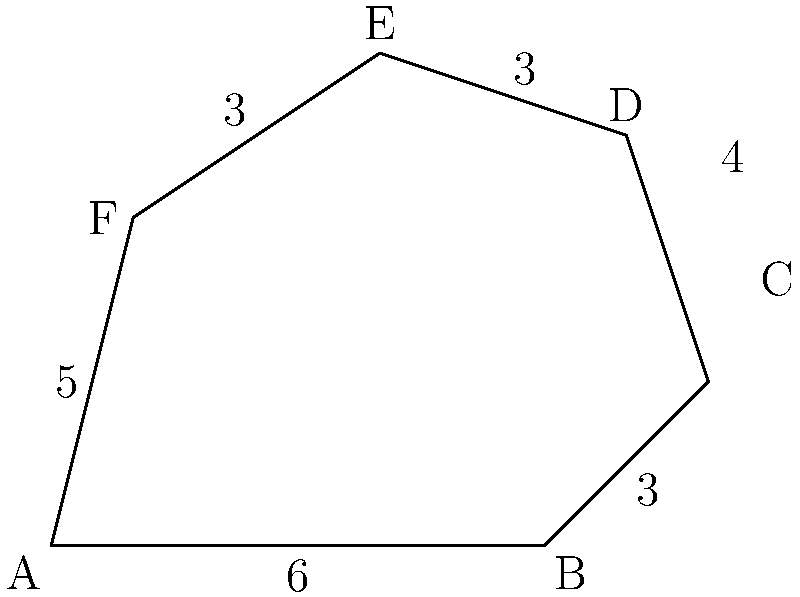Your favorite influencer just posted a picture of a trendy designer handbag with an irregular hexagonal shape. The dimensions of the handbag are shown in the diagram above. Calculate the area of the handbag's shape to determine how much fabric would be needed to create a similar design. To find the area of this irregular hexagon, we can divide it into triangles and calculate their areas:

1. Divide the hexagon into four triangles: ABC, ACD, ADE, and AEF.

2. Calculate the areas of each triangle:

   a) Triangle ABC:
      Base = 6, Height = 2
      Area = $\frac{1}{2} \times 6 \times 2 = 6$ square units

   b) Triangle ACD:
      We need to find AC first using the Pythagorean theorem:
      $AC^2 = 6^2 + 2^2 = 40$
      $AC = \sqrt{40} = 2\sqrt{10}$
      
      Now we can use Heron's formula:
      $s = \frac{2\sqrt{10} + 4 + 7}{2} = \frac{7 + 2\sqrt{10}}{2}$
      Area = $\sqrt{s(s-2\sqrt{10})(s-4)(s-7)}$
      $= \sqrt{\frac{7 + 2\sqrt{10}}{2} \times \frac{7 - 2\sqrt{10}}{2} \times \frac{3 + 2\sqrt{10}}{2} \times \frac{-7 + 2\sqrt{10}}{2}}$
      $= \frac{\sqrt{49 - 40 + 21 + 2\sqrt{10} - 49 + 2\sqrt{10}}}{2} = \frac{\sqrt{30 + 4\sqrt{10}}}{2}$
      $= \frac{\sqrt{30 + 4\sqrt{10}}}{2} \approx 5.2$ square units

   c) Triangle ADE:
      Base = 7, Height = 3
      Area = $\frac{1}{2} \times 7 \times 3 = 10.5$ square units

   d) Triangle AEF:
      Base = 5, Height = 4
      Area = $\frac{1}{2} \times 5 \times 4 = 10$ square units

3. Sum up all the areas:
   Total Area = 6 + 5.2 + 10.5 + 10 = 31.7 square units

Therefore, the area of the handbag's shape is approximately 31.7 square units.
Answer: 31.7 square units 